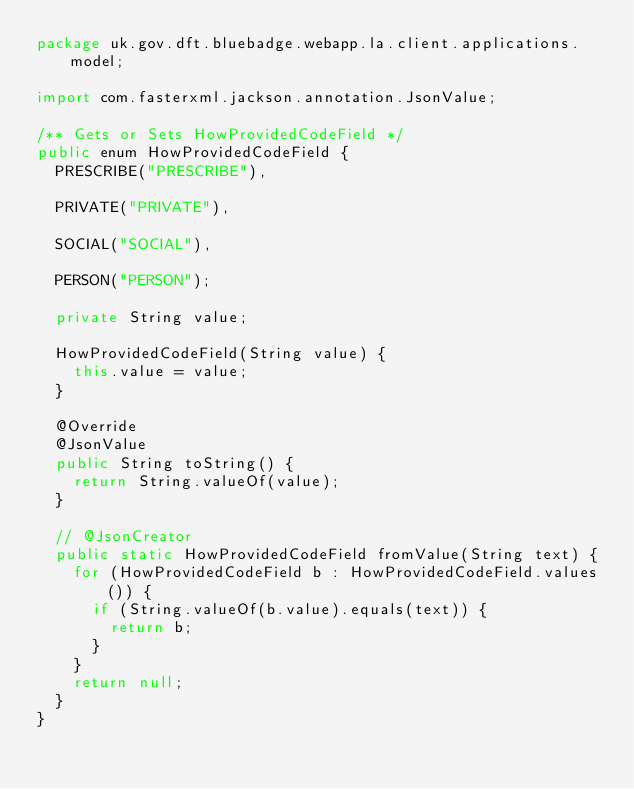<code> <loc_0><loc_0><loc_500><loc_500><_Java_>package uk.gov.dft.bluebadge.webapp.la.client.applications.model;

import com.fasterxml.jackson.annotation.JsonValue;

/** Gets or Sets HowProvidedCodeField */
public enum HowProvidedCodeField {
  PRESCRIBE("PRESCRIBE"),

  PRIVATE("PRIVATE"),

  SOCIAL("SOCIAL"),

  PERSON("PERSON");

  private String value;

  HowProvidedCodeField(String value) {
    this.value = value;
  }

  @Override
  @JsonValue
  public String toString() {
    return String.valueOf(value);
  }

  // @JsonCreator
  public static HowProvidedCodeField fromValue(String text) {
    for (HowProvidedCodeField b : HowProvidedCodeField.values()) {
      if (String.valueOf(b.value).equals(text)) {
        return b;
      }
    }
    return null;
  }
}
</code> 